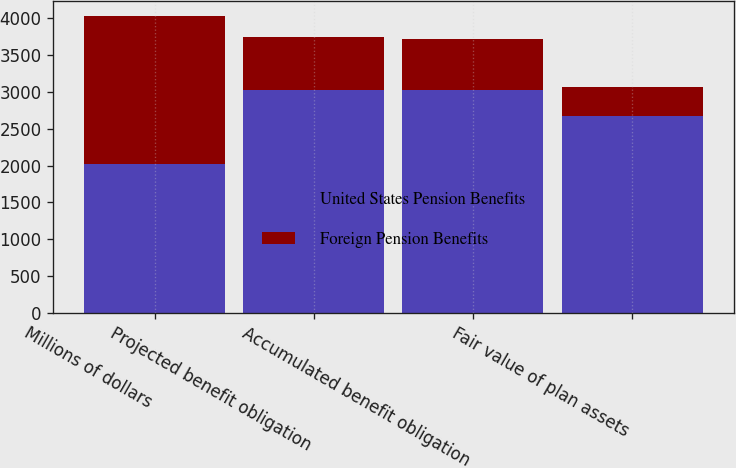Convert chart. <chart><loc_0><loc_0><loc_500><loc_500><stacked_bar_chart><ecel><fcel>Millions of dollars<fcel>Projected benefit obligation<fcel>Accumulated benefit obligation<fcel>Fair value of plan assets<nl><fcel>United States Pension Benefits<fcel>2018<fcel>3033<fcel>3022<fcel>2676<nl><fcel>Foreign Pension Benefits<fcel>2018<fcel>720<fcel>699<fcel>396<nl></chart> 